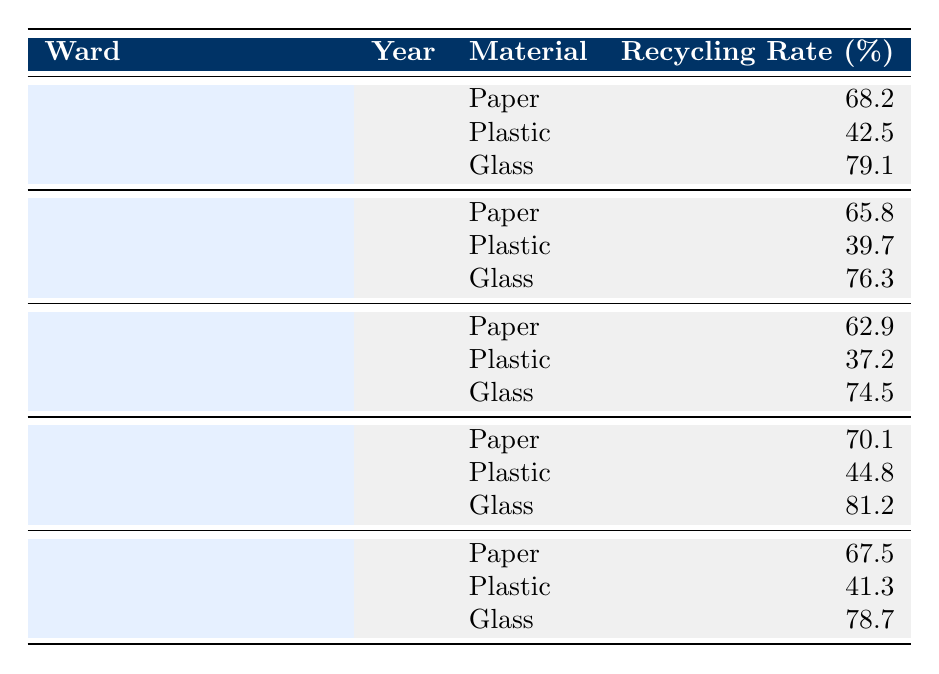What is the recycling rate of glass in Thaxted & The Eastons? The table shows the recycling rates for different materials in each ward for the year 2022. For Thaxted & The Eastons, the recycling rate for glass is explicitly stated as 81.2%.
Answer: 81.2% Which ward has the highest recycling rate for paper? By examining the recycling rates for paper in the table, Thaxted & The Eastons has the highest rate at 70.1%.
Answer: Thaxted & The Eastons What is the average recycling rate for plastic across all wards? To calculate the average recycling rate for plastic, we need to sum the individual rates: (42.5 + 39.7 + 37.2 + 44.8 + 41.3) = 205.5. There are 5 rates, so the average is 205.5 / 5 = 41.1.
Answer: 41.1 Is the recycling rate for glass higher than that for plastic in Saffron Walden Audley? The recycling rates for Saffron Walden Audley show that glass has a rate of 79.1% and plastic has a rate of 42.5%. Since 79.1% is greater than 42.5%, the statement is true.
Answer: Yes What is the difference in recycling rates for paper between Great Dunmow North and Stansted North? The recycling rate for paper in Great Dunmow North is 65.8%, and in Stansted North, it is 62.9%. The difference is 65.8 - 62.9 = 2.9%.
Answer: 2.9% Which material has the lowest recycling rate in Stansted North? In Stansted North, the recycling rates by material are: Paper (62.9%), Plastic (37.2%), Glass (74.5%). The lowest recycling rate is for plastic, at 37.2%.
Answer: Plastic How do the recycling rates for paper compare between Saffron Walden Audley and Felsted & Stebbing? The recycling rate for paper in Saffron Walden Audley is 68.2% and in Felsted & Stebbing is 67.5%. Since 68.2% is greater than 67.5%, Saffron Walden Audley has a higher rate.
Answer: Saffron Walden Audley is higher Which ward shows the best overall recycling rate for glass, and what is that rate? Looking at the glass recycling rates, Thaxted & The Eastons has the highest rate at 81.2%. This indicates that it shows the best overall performance for glass recycling.
Answer: Thaxted & The Eastons, 81.2% Are the average recycling rates for paper in Saffron Walden Audley and Great Dunmow North higher than 65%? Saffron Walden Audley has a paper recycling rate of 68.2%, and Great Dunmow North has a rate of 65.8%. Both are greater than 65%. Thus, the answer is yes.
Answer: Yes What is the highest recycling rate among all wards for any material, and which material is it? The rates show that the highest recycling rate is 81.2% for glass in Thaxted & The Eastons, which stands as the top value across all materials and wards.
Answer: 81.2%, Glass 